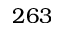<formula> <loc_0><loc_0><loc_500><loc_500>2 6 3</formula> 